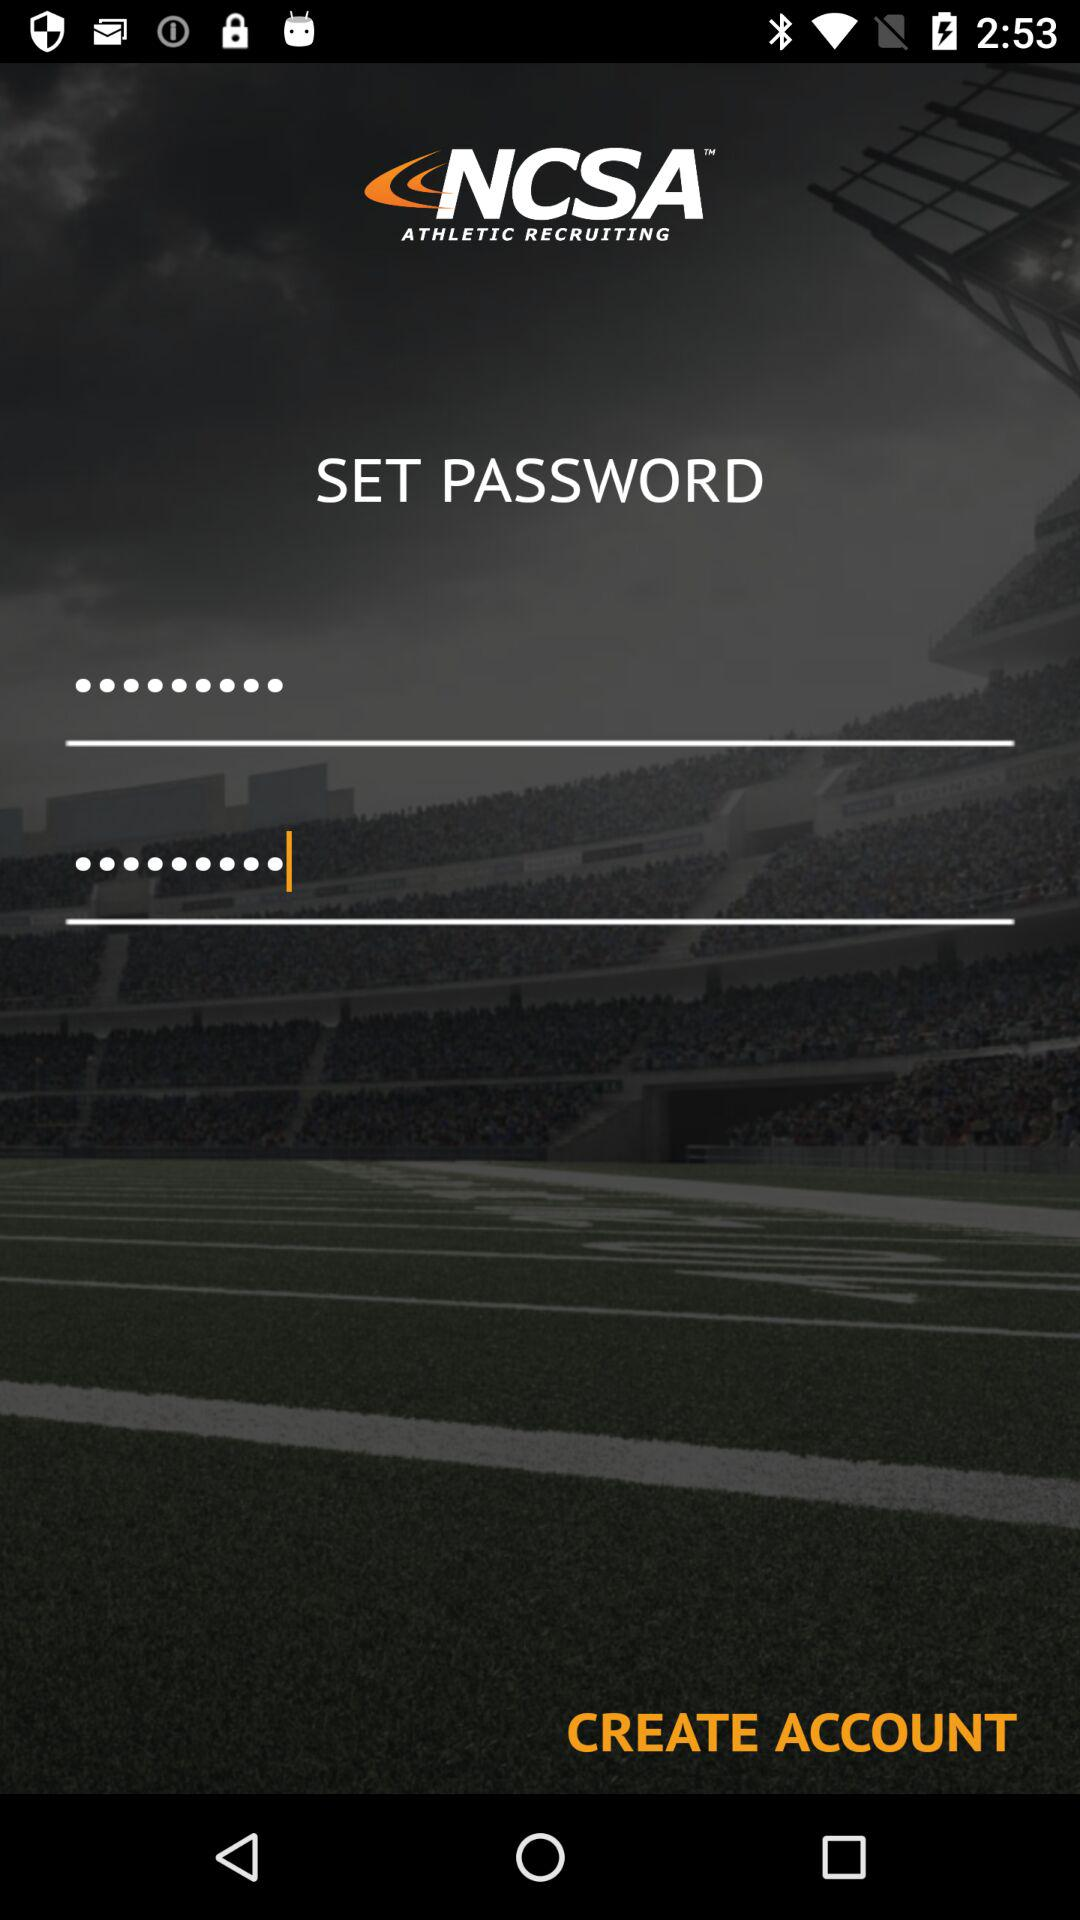What is the name of the application? The name of the application is "NCSA". 